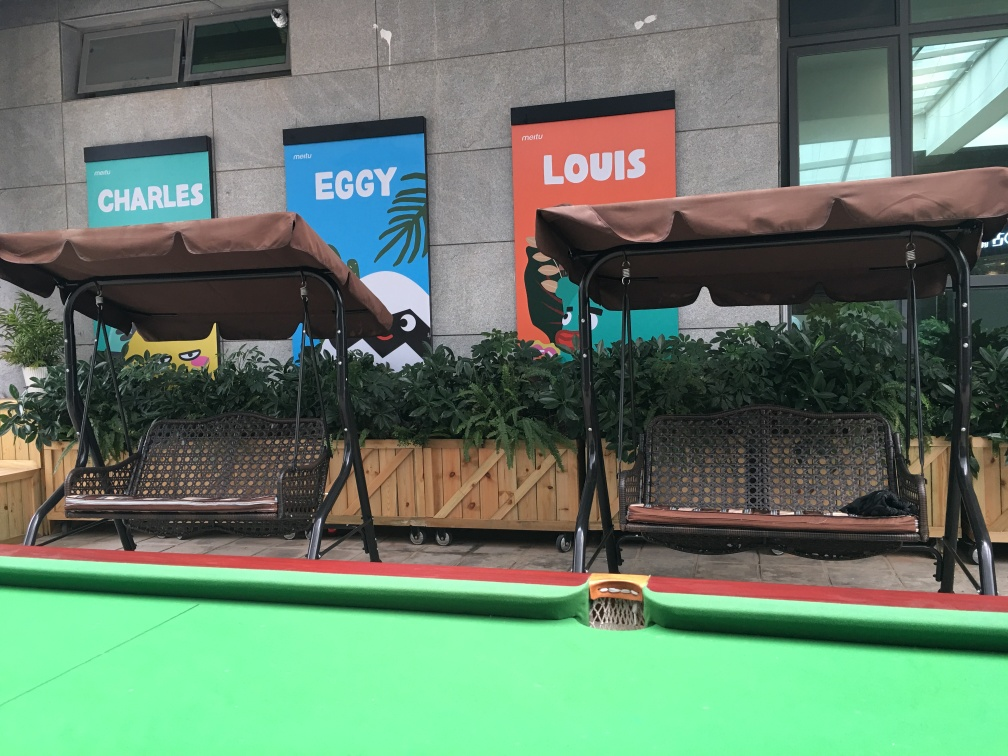What is the purpose of the benches in this image? The benches offer a comfortable seating option for individuals to relax, possibly while waiting for a service or enjoying the outdoor ambiance. Their design allows for gentle swaying motions, adding to the overall casual and leisurely atmosphere of the setting. Could you comment on the design and material of the benches? The benches have a traditional swing design with a metal frame and suspended seating featuring a woven pattern, which appears to be made of a durable material suitable for outdoor conditions. The canopy on top provides shade and shelter from the elements, enhancing the comfort of the seating area. 